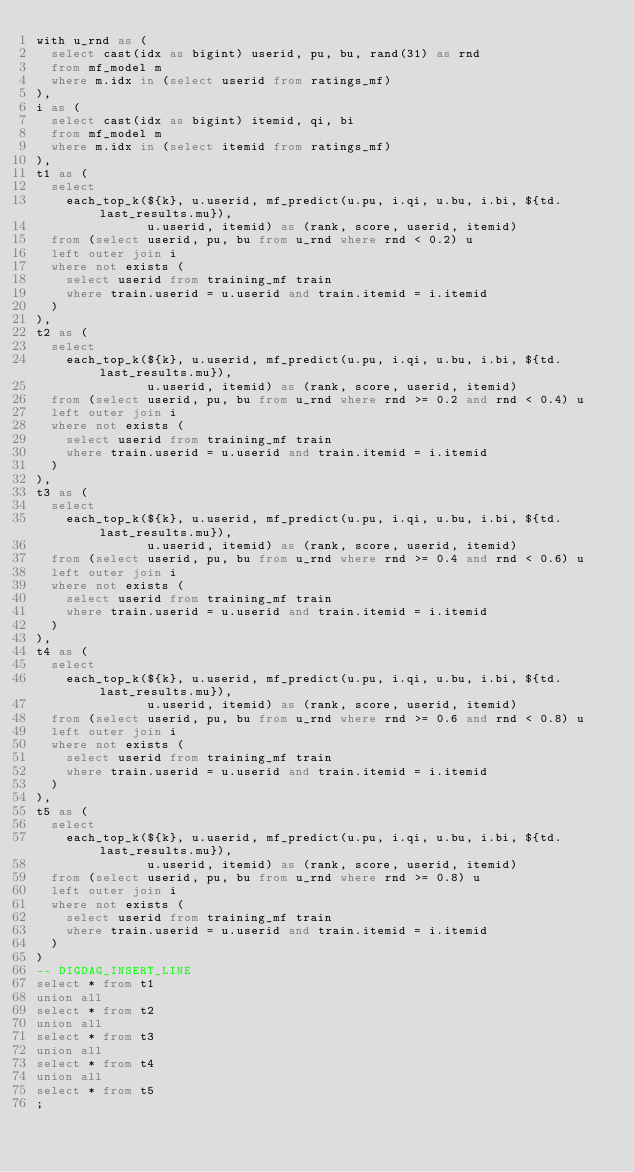<code> <loc_0><loc_0><loc_500><loc_500><_SQL_>with u_rnd as (
  select cast(idx as bigint) userid, pu, bu, rand(31) as rnd
  from mf_model m
  where m.idx in (select userid from ratings_mf)
),
i as (
  select cast(idx as bigint) itemid, qi, bi
  from mf_model m
  where m.idx in (select itemid from ratings_mf)
),
t1 as (
  select
    each_top_k(${k}, u.userid, mf_predict(u.pu, i.qi, u.bu, i.bi, ${td.last_results.mu}),
               u.userid, itemid) as (rank, score, userid, itemid)
  from (select userid, pu, bu from u_rnd where rnd < 0.2) u
  left outer join i
  where not exists (
    select userid from training_mf train
    where train.userid = u.userid and train.itemid = i.itemid
  )
),
t2 as (
  select
    each_top_k(${k}, u.userid, mf_predict(u.pu, i.qi, u.bu, i.bi, ${td.last_results.mu}),
               u.userid, itemid) as (rank, score, userid, itemid)
  from (select userid, pu, bu from u_rnd where rnd >= 0.2 and rnd < 0.4) u
  left outer join i
  where not exists (
    select userid from training_mf train
    where train.userid = u.userid and train.itemid = i.itemid
  )
),
t3 as (
  select
    each_top_k(${k}, u.userid, mf_predict(u.pu, i.qi, u.bu, i.bi, ${td.last_results.mu}),
               u.userid, itemid) as (rank, score, userid, itemid)
  from (select userid, pu, bu from u_rnd where rnd >= 0.4 and rnd < 0.6) u
  left outer join i
  where not exists (
    select userid from training_mf train
    where train.userid = u.userid and train.itemid = i.itemid
  )
),
t4 as (
  select
    each_top_k(${k}, u.userid, mf_predict(u.pu, i.qi, u.bu, i.bi, ${td.last_results.mu}),
               u.userid, itemid) as (rank, score, userid, itemid)
  from (select userid, pu, bu from u_rnd where rnd >= 0.6 and rnd < 0.8) u
  left outer join i
  where not exists (
    select userid from training_mf train
    where train.userid = u.userid and train.itemid = i.itemid
  )
),
t5 as (
  select
    each_top_k(${k}, u.userid, mf_predict(u.pu, i.qi, u.bu, i.bi, ${td.last_results.mu}),
               u.userid, itemid) as (rank, score, userid, itemid)
  from (select userid, pu, bu from u_rnd where rnd >= 0.8) u
  left outer join i
  where not exists (
    select userid from training_mf train
    where train.userid = u.userid and train.itemid = i.itemid
  )
)
-- DIGDAG_INSERT_LINE
select * from t1
union all
select * from t2
union all
select * from t3
union all
select * from t4
union all
select * from t5
;
</code> 